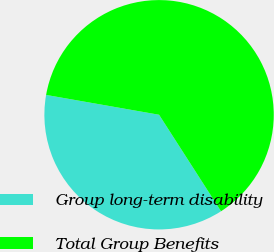Convert chart to OTSL. <chart><loc_0><loc_0><loc_500><loc_500><pie_chart><fcel>Group long-term disability<fcel>Total Group Benefits<nl><fcel>36.85%<fcel>63.15%<nl></chart> 